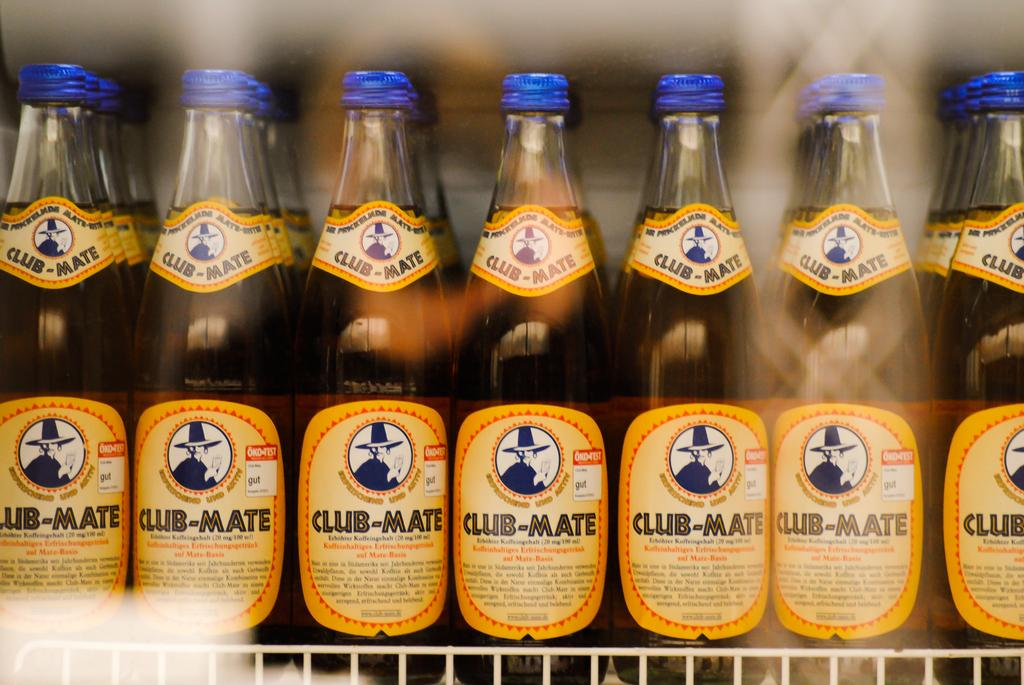<image>
Share a concise interpretation of the image provided. Man bottles of Club-Mate with a blue cap next to one another. 